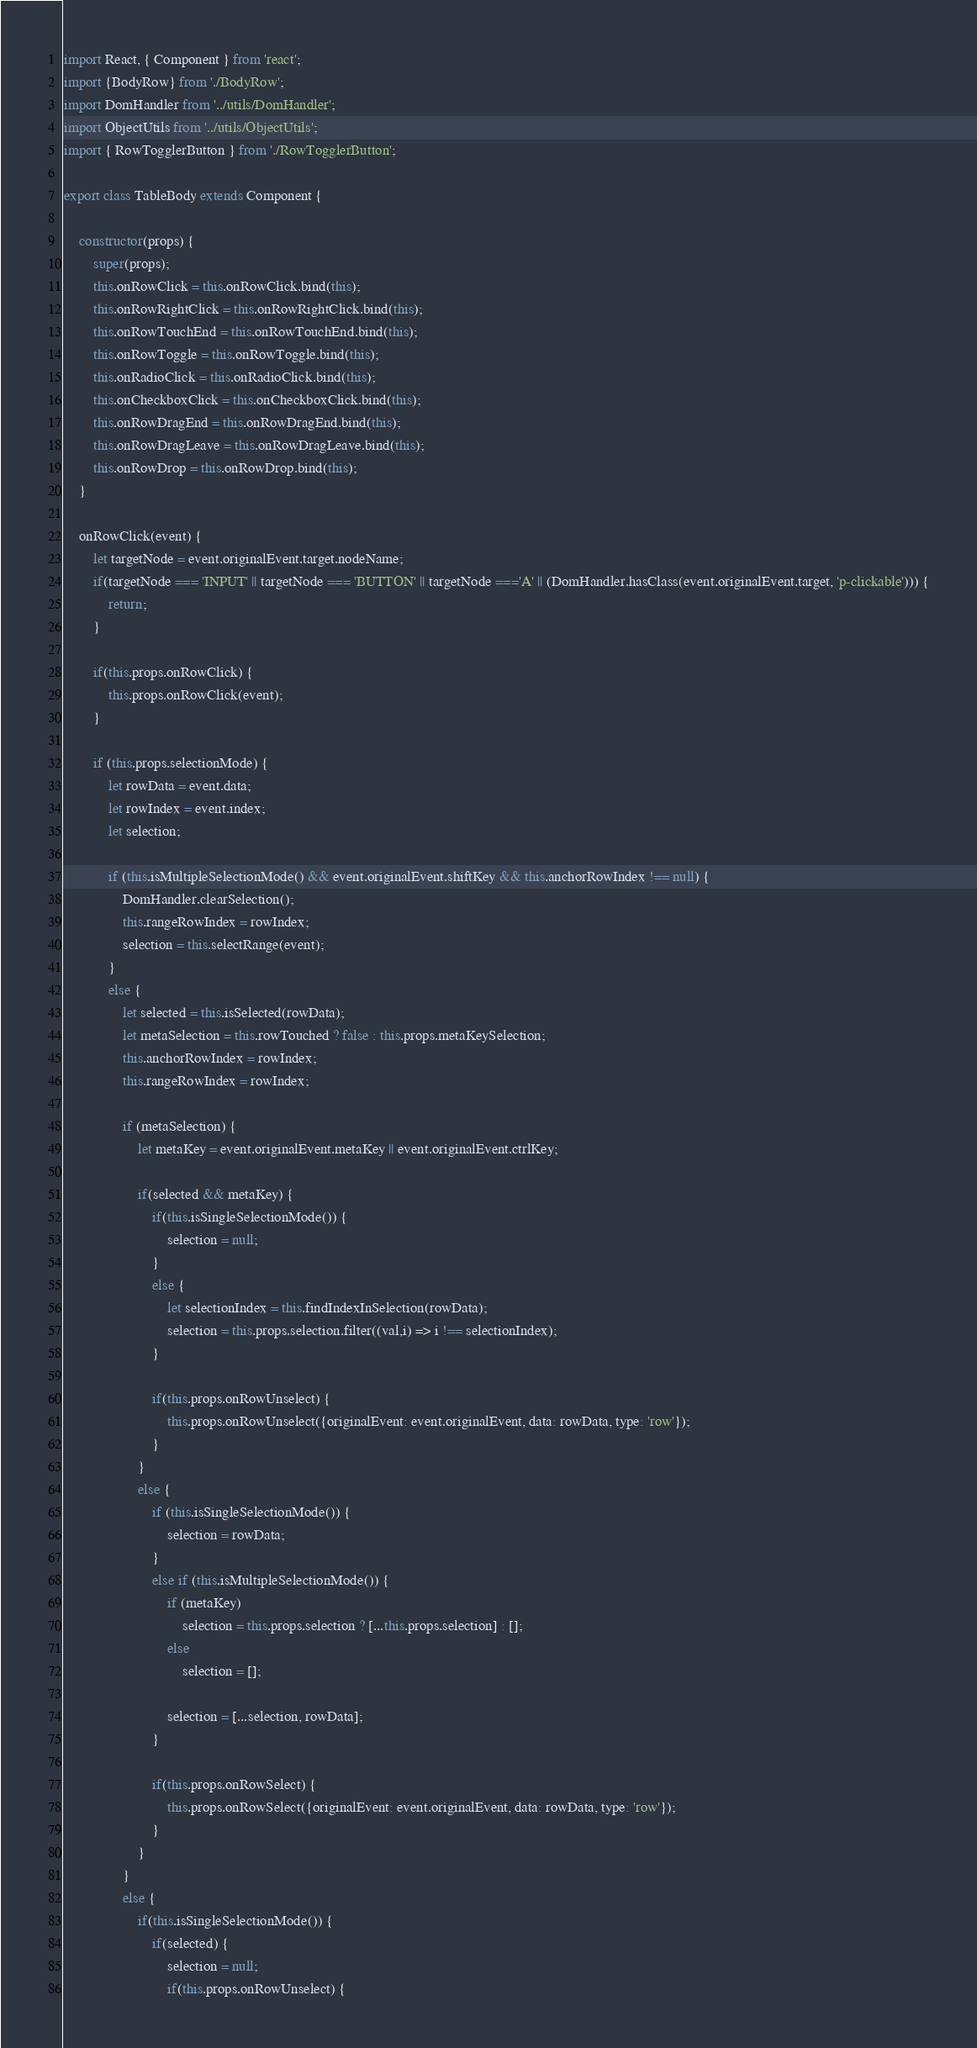Convert code to text. <code><loc_0><loc_0><loc_500><loc_500><_JavaScript_>import React, { Component } from 'react';
import {BodyRow} from './BodyRow';
import DomHandler from '../utils/DomHandler';
import ObjectUtils from '../utils/ObjectUtils';
import { RowTogglerButton } from './RowTogglerButton';

export class TableBody extends Component {

    constructor(props) {
        super(props);
        this.onRowClick = this.onRowClick.bind(this);
        this.onRowRightClick = this.onRowRightClick.bind(this);
        this.onRowTouchEnd = this.onRowTouchEnd.bind(this);
        this.onRowToggle = this.onRowToggle.bind(this);
        this.onRadioClick = this.onRadioClick.bind(this);
        this.onCheckboxClick = this.onCheckboxClick.bind(this);
        this.onRowDragEnd = this.onRowDragEnd.bind(this);
        this.onRowDragLeave = this.onRowDragLeave.bind(this);
        this.onRowDrop = this.onRowDrop.bind(this);
    }

    onRowClick(event) {
        let targetNode = event.originalEvent.target.nodeName;
        if(targetNode === 'INPUT' || targetNode === 'BUTTON' || targetNode ==='A' || (DomHandler.hasClass(event.originalEvent.target, 'p-clickable'))) {
            return;
        }

        if(this.props.onRowClick) {
            this.props.onRowClick(event);
        }

        if (this.props.selectionMode) {
            let rowData = event.data;
            let rowIndex = event.index;
            let selection;

            if (this.isMultipleSelectionMode() && event.originalEvent.shiftKey && this.anchorRowIndex !== null) {
                DomHandler.clearSelection();
                this.rangeRowIndex = rowIndex;
                selection = this.selectRange(event);
            }
            else {
                let selected = this.isSelected(rowData);
                let metaSelection = this.rowTouched ? false : this.props.metaKeySelection;
                this.anchorRowIndex = rowIndex;
                this.rangeRowIndex = rowIndex;

                if (metaSelection) {
                    let metaKey = event.originalEvent.metaKey || event.originalEvent.ctrlKey;

                    if(selected && metaKey) {
                        if(this.isSingleSelectionMode()) {
                            selection = null;
                        }
                        else {
                            let selectionIndex = this.findIndexInSelection(rowData);
                            selection = this.props.selection.filter((val,i) => i !== selectionIndex);
                        }

                        if(this.props.onRowUnselect) {
                            this.props.onRowUnselect({originalEvent: event.originalEvent, data: rowData, type: 'row'});
                        }
                    }
                    else {
                        if (this.isSingleSelectionMode()) {
                            selection = rowData;
                        }
                        else if (this.isMultipleSelectionMode()) {
                            if (metaKey)
                                selection = this.props.selection ? [...this.props.selection] : [];
                            else
                                selection = [];

                            selection = [...selection, rowData];
                        }

                        if(this.props.onRowSelect) {
                            this.props.onRowSelect({originalEvent: event.originalEvent, data: rowData, type: 'row'});
                        }
                    }
                }
                else {
                    if(this.isSingleSelectionMode()) {
                        if(selected) {
                            selection = null;
                            if(this.props.onRowUnselect) {</code> 